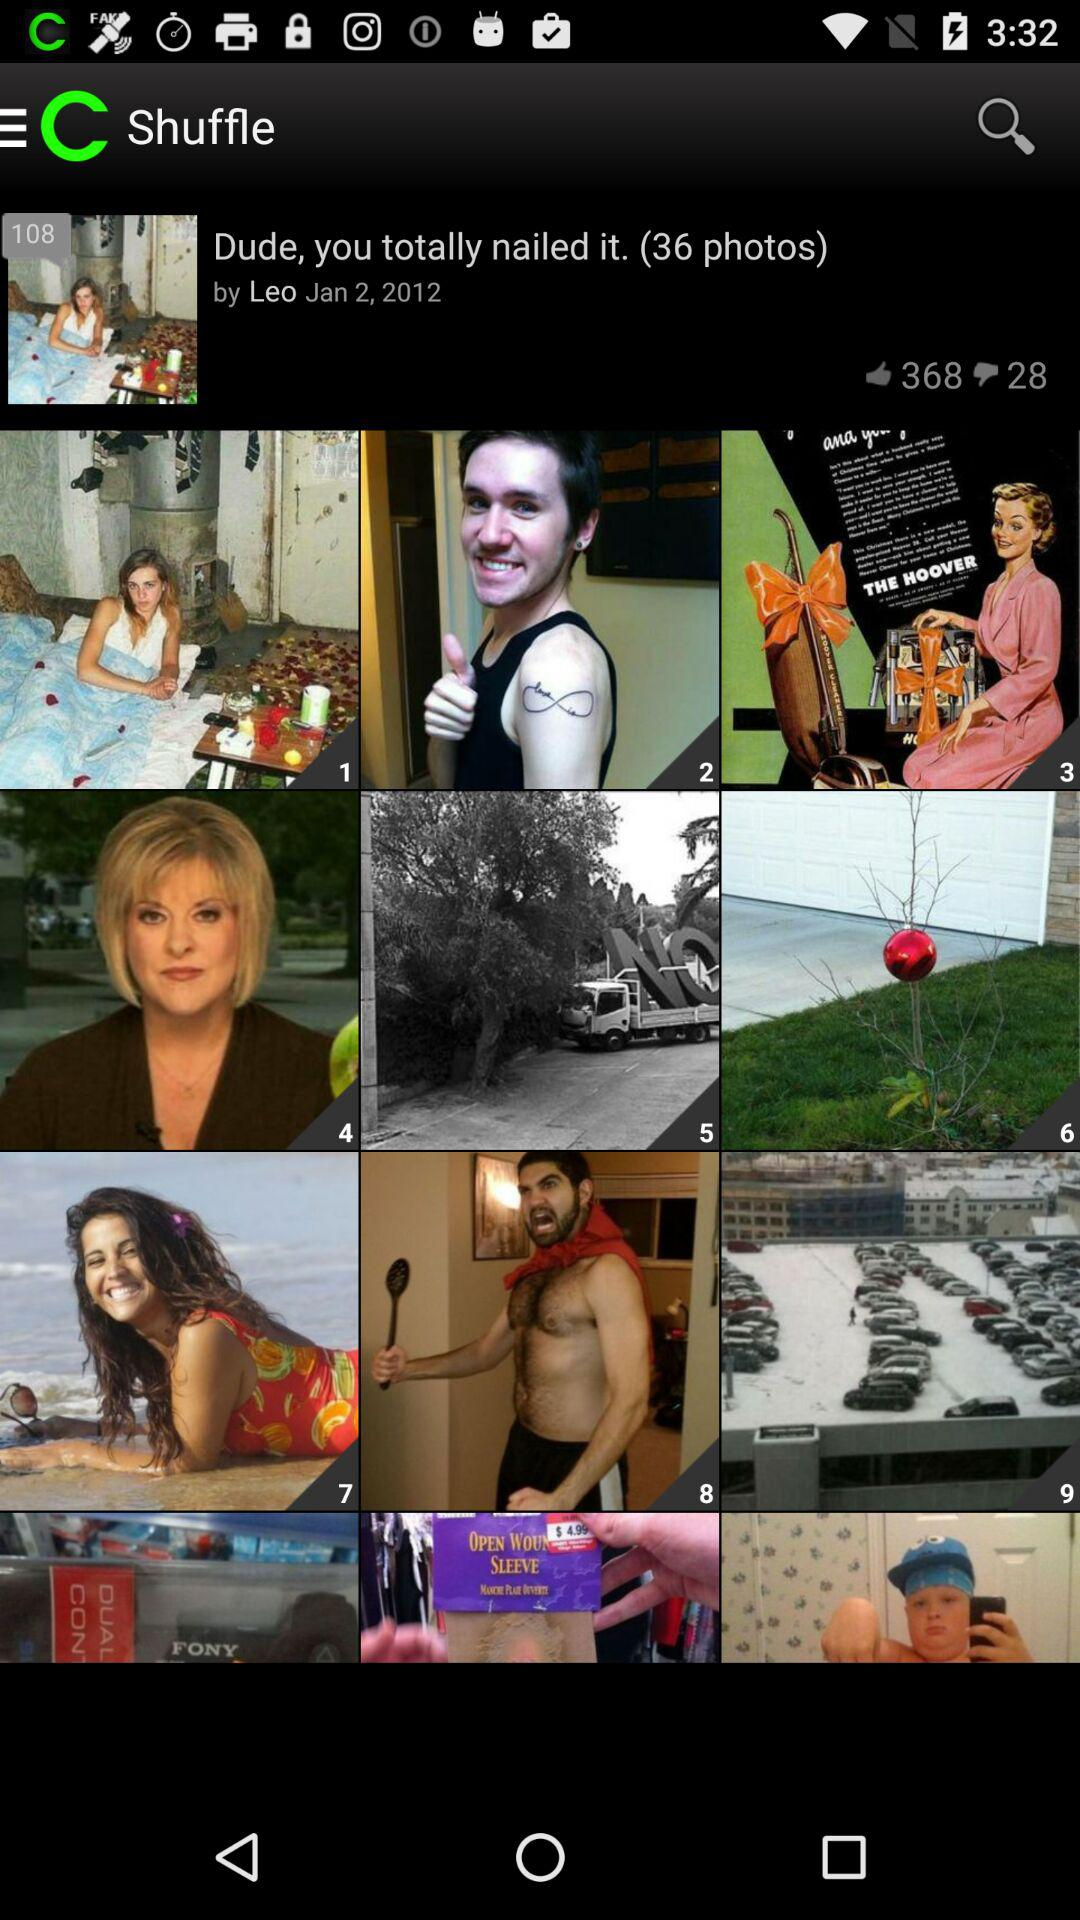What is the posted date? The posted date is January 2, 2012. 